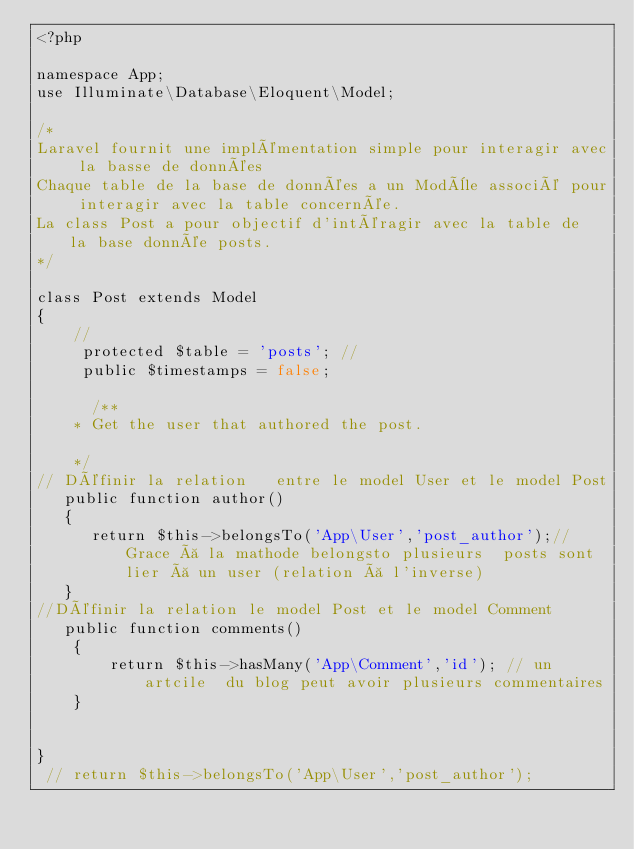Convert code to text. <code><loc_0><loc_0><loc_500><loc_500><_PHP_><?php

namespace App;
use Illuminate\Database\Eloquent\Model;

/*
Laravel fournit une implémentation simple pour interagir avec la basse de données
Chaque table de la base de données a un Modèle associé pour interagir avec la table concernée.
La class Post a pour objectif d'intéragir avec la table de  la base donnée posts. 
*/

class Post extends Model
{
    //
     protected $table = 'posts'; // 
     public $timestamps = false;

      /**
    * Get the user that authored the post.

    */
// Définir la relation   entre le model User et le model Post
   public function author()
   {
      return $this->belongsTo('App\User','post_author');// Grace à la mathode belongsto plusieurs  posts sont lier à un user (relation à l'inverse)
   }
//Définir la relation le model Post et le model Comment 
   public function comments()
    {
        return $this->hasMany('App\Comment','id'); // un artcile  du blog peut avoir plusieurs commentaires 
    }


}
 // return $this->belongsTo('App\User','post_author');
</code> 